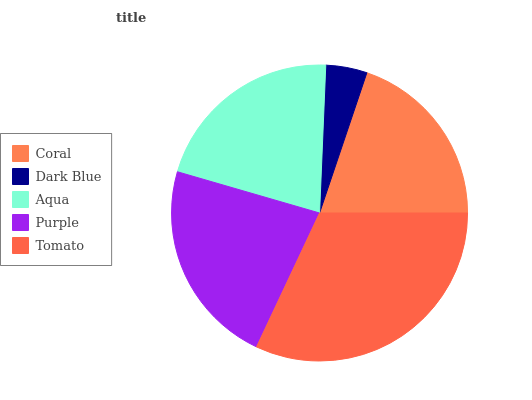Is Dark Blue the minimum?
Answer yes or no. Yes. Is Tomato the maximum?
Answer yes or no. Yes. Is Aqua the minimum?
Answer yes or no. No. Is Aqua the maximum?
Answer yes or no. No. Is Aqua greater than Dark Blue?
Answer yes or no. Yes. Is Dark Blue less than Aqua?
Answer yes or no. Yes. Is Dark Blue greater than Aqua?
Answer yes or no. No. Is Aqua less than Dark Blue?
Answer yes or no. No. Is Aqua the high median?
Answer yes or no. Yes. Is Aqua the low median?
Answer yes or no. Yes. Is Purple the high median?
Answer yes or no. No. Is Coral the low median?
Answer yes or no. No. 